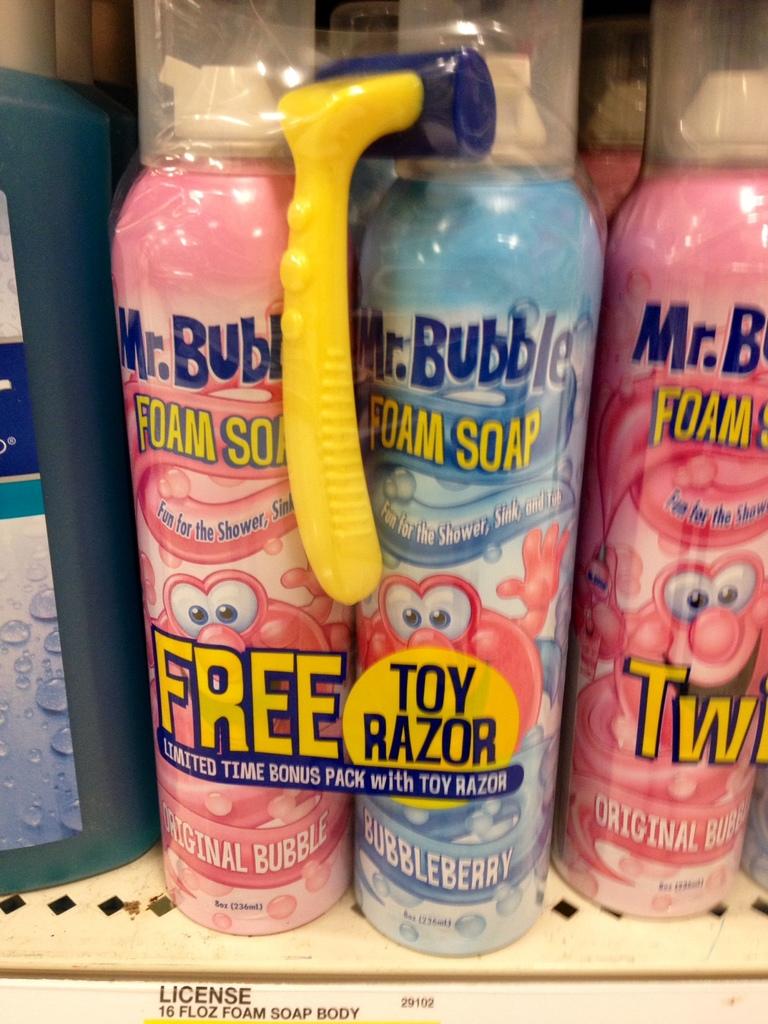What type of foam is this?
Your response must be concise. Foam soap. What do you get free?
Offer a terse response. Toy razor. 